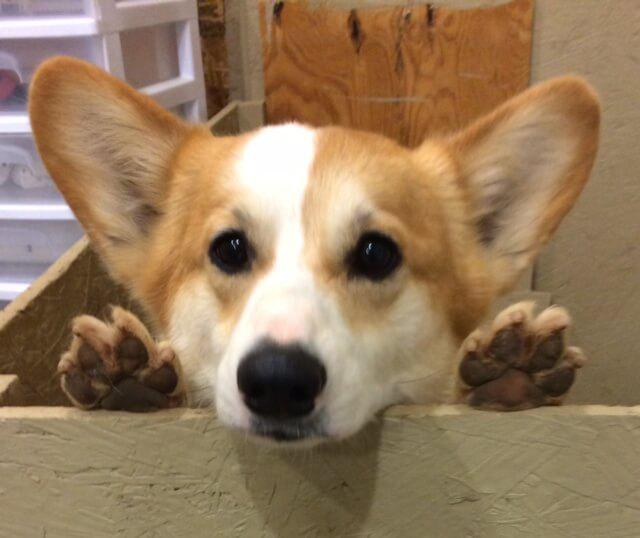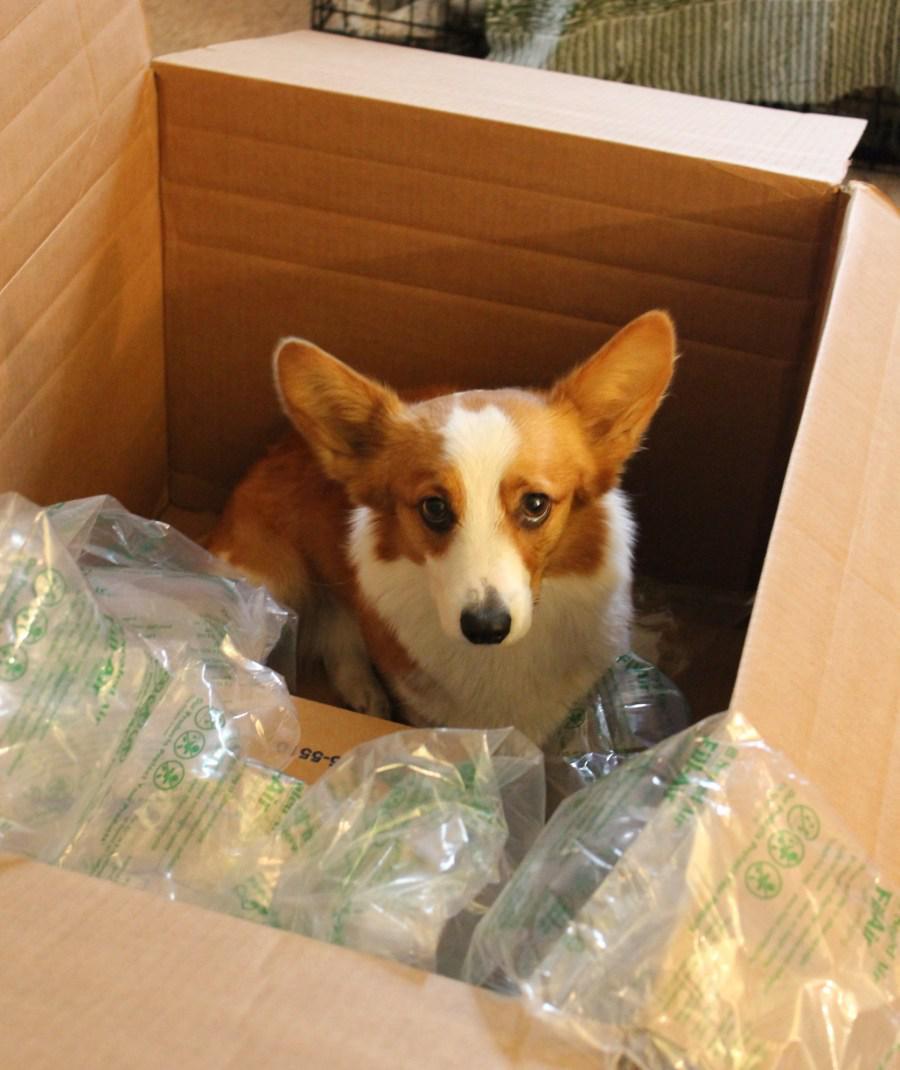The first image is the image on the left, the second image is the image on the right. Evaluate the accuracy of this statement regarding the images: "A dog is in a brown cardboard box with its flaps folding outward instead of tucked inward.". Is it true? Answer yes or no. Yes. 